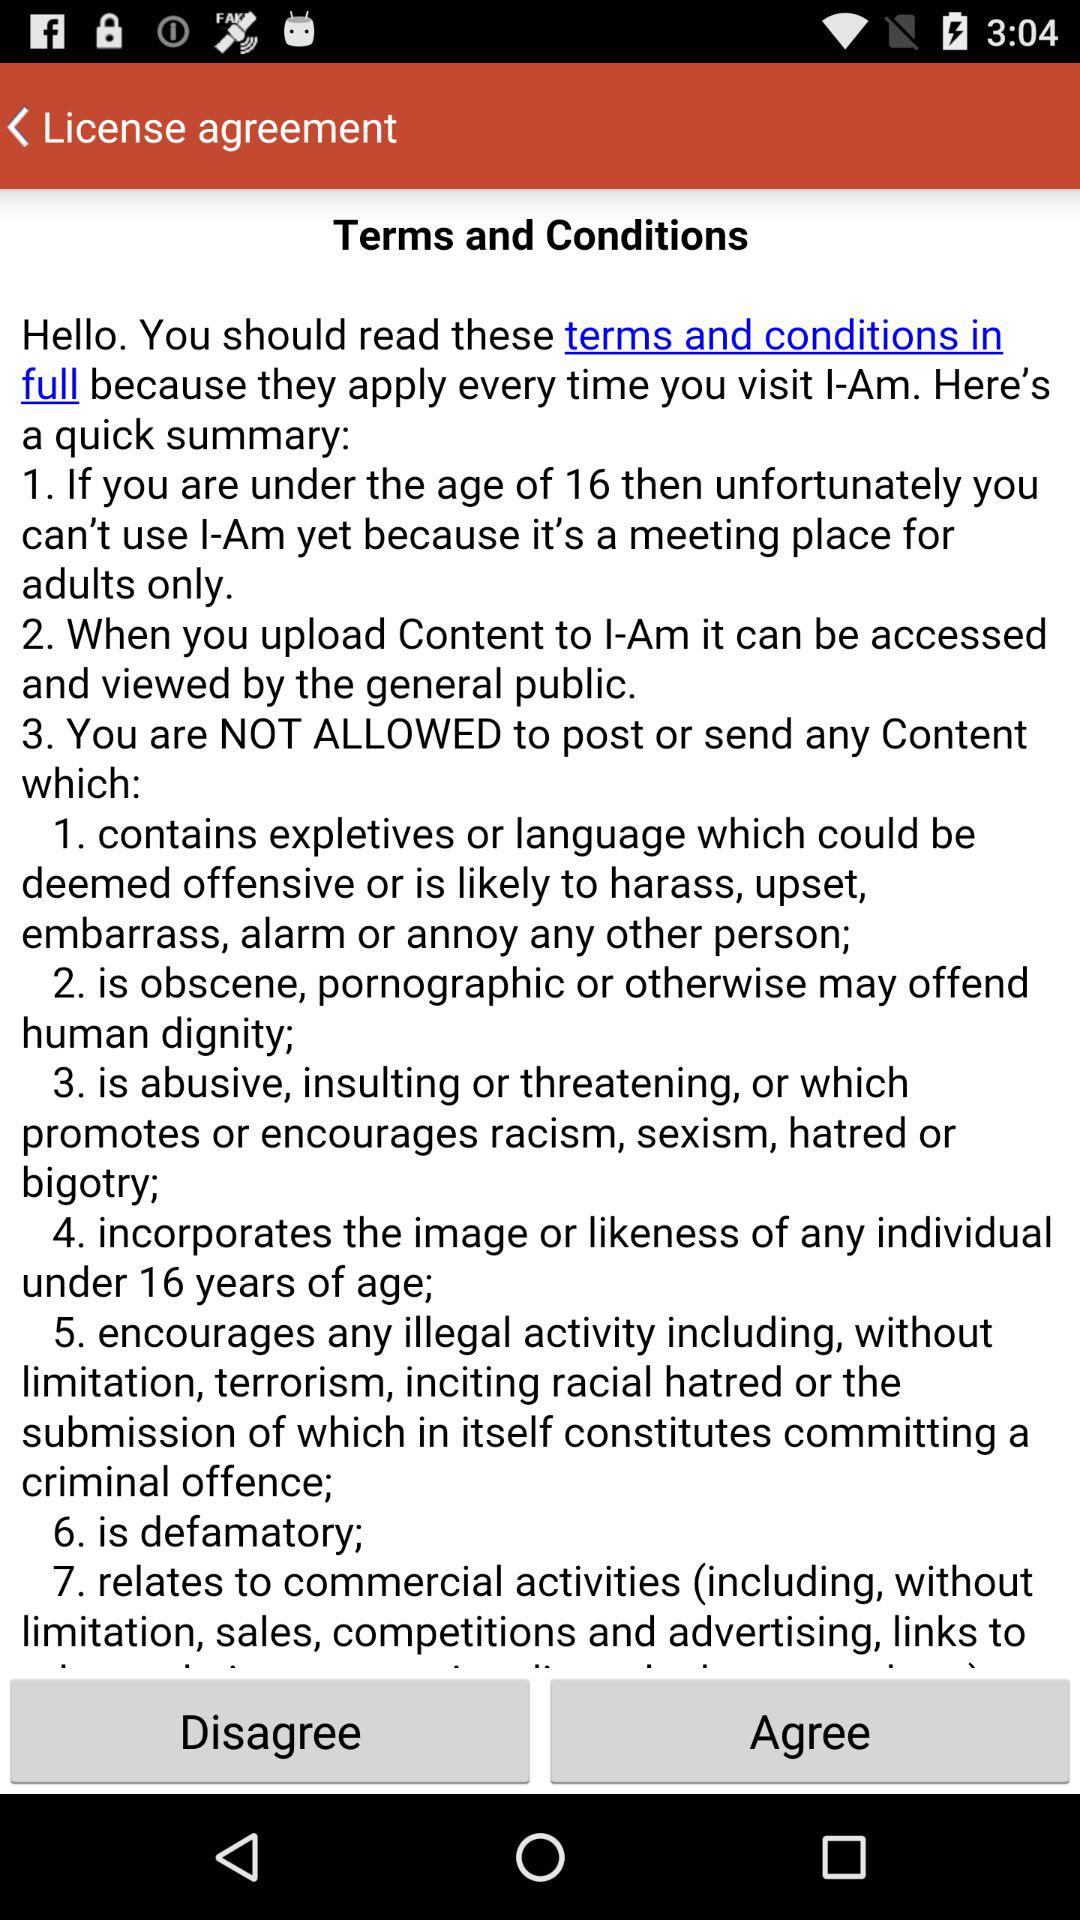How many terms are there in the terms and conditions?
Answer the question using a single word or phrase. 7 